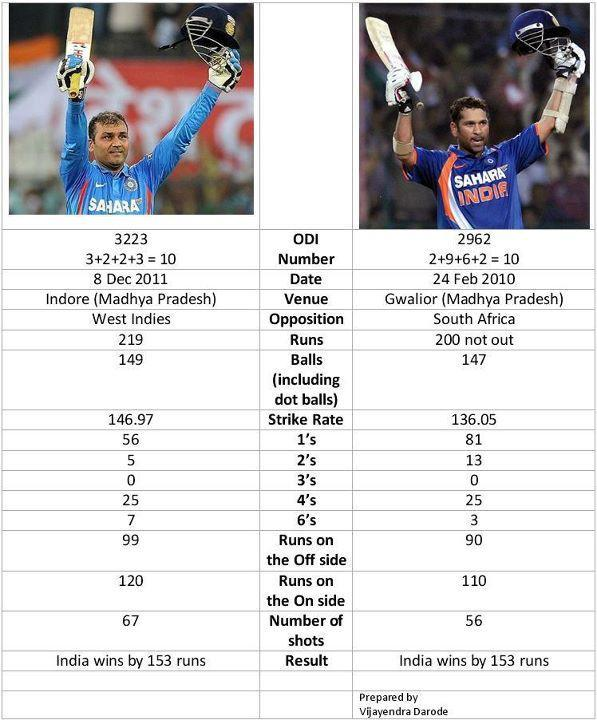In which ODI was 7 sixes scored?
Answer the question with a short phrase. 3223 ODI number 3223 was played at which place? Indore (Madhya Pradesh) When was the ODI 3223 match held? 8 Dec 2011 Against which team did was ODI 2962 played? South Africa ODI 3223 was played against which team? West Indies What was the match number of the ODI played on 24 Feb 2010? 2962 At which place was ODI 2962 played? Gwalior (Madhya Pradesh) 